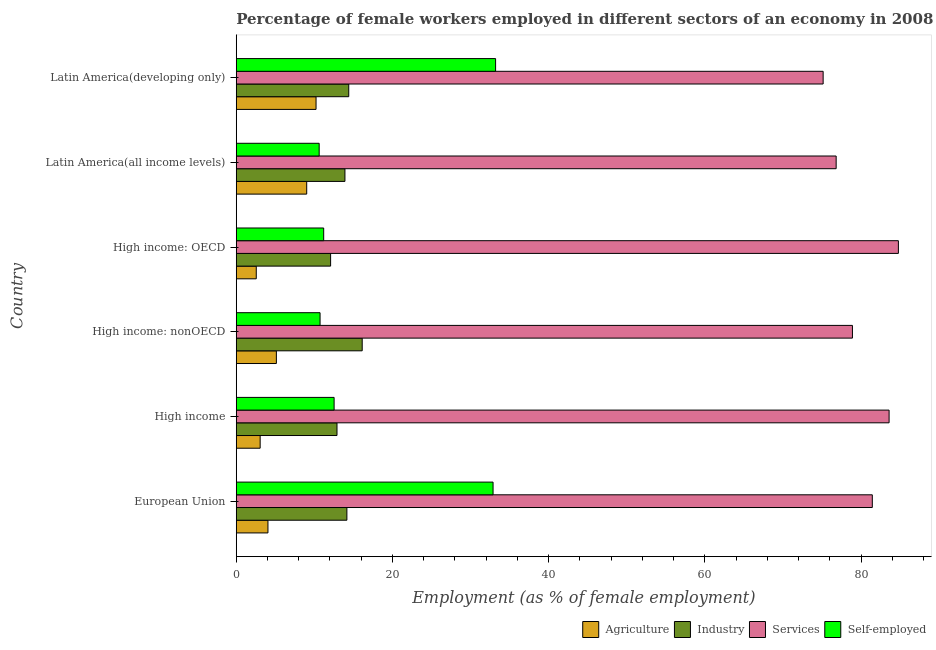How many different coloured bars are there?
Make the answer very short. 4. Are the number of bars per tick equal to the number of legend labels?
Offer a terse response. Yes. How many bars are there on the 3rd tick from the top?
Offer a very short reply. 4. How many bars are there on the 2nd tick from the bottom?
Your answer should be very brief. 4. In how many cases, is the number of bars for a given country not equal to the number of legend labels?
Offer a very short reply. 0. What is the percentage of female workers in industry in High income: OECD?
Keep it short and to the point. 12.08. Across all countries, what is the maximum percentage of female workers in agriculture?
Your answer should be very brief. 10.22. Across all countries, what is the minimum percentage of female workers in services?
Your answer should be very brief. 75.15. In which country was the percentage of female workers in services maximum?
Your answer should be compact. High income: OECD. In which country was the percentage of self employed female workers minimum?
Your answer should be compact. Latin America(all income levels). What is the total percentage of self employed female workers in the graph?
Give a very brief answer. 111.16. What is the difference between the percentage of self employed female workers in High income and that in High income: OECD?
Ensure brevity in your answer.  1.33. What is the difference between the percentage of female workers in agriculture in High income: nonOECD and the percentage of female workers in industry in Latin America(all income levels)?
Provide a short and direct response. -8.78. What is the average percentage of female workers in agriculture per country?
Make the answer very short. 5.68. What is the difference between the percentage of female workers in agriculture and percentage of female workers in services in High income?
Your response must be concise. -80.53. In how many countries, is the percentage of female workers in industry greater than 56 %?
Ensure brevity in your answer.  0. What is the ratio of the percentage of female workers in agriculture in European Union to that in High income?
Give a very brief answer. 1.33. Is the difference between the percentage of self employed female workers in Latin America(all income levels) and Latin America(developing only) greater than the difference between the percentage of female workers in industry in Latin America(all income levels) and Latin America(developing only)?
Your answer should be compact. No. What is the difference between the highest and the second highest percentage of self employed female workers?
Make the answer very short. 0.32. What is the difference between the highest and the lowest percentage of female workers in services?
Make the answer very short. 9.63. What does the 4th bar from the top in High income represents?
Provide a succinct answer. Agriculture. What does the 1st bar from the bottom in High income represents?
Your answer should be very brief. Agriculture. Is it the case that in every country, the sum of the percentage of female workers in agriculture and percentage of female workers in industry is greater than the percentage of female workers in services?
Offer a very short reply. No. How many bars are there?
Your answer should be compact. 24. How many countries are there in the graph?
Make the answer very short. 6. Does the graph contain any zero values?
Offer a terse response. No. How many legend labels are there?
Offer a terse response. 4. What is the title of the graph?
Offer a terse response. Percentage of female workers employed in different sectors of an economy in 2008. What is the label or title of the X-axis?
Make the answer very short. Employment (as % of female employment). What is the Employment (as % of female employment) in Agriculture in European Union?
Your response must be concise. 4.06. What is the Employment (as % of female employment) of Industry in European Union?
Keep it short and to the point. 14.17. What is the Employment (as % of female employment) of Services in European Union?
Provide a succinct answer. 81.44. What is the Employment (as % of female employment) in Self-employed in European Union?
Your response must be concise. 32.88. What is the Employment (as % of female employment) of Agriculture in High income?
Provide a short and direct response. 3.06. What is the Employment (as % of female employment) of Industry in High income?
Your answer should be very brief. 12.9. What is the Employment (as % of female employment) in Services in High income?
Give a very brief answer. 83.59. What is the Employment (as % of female employment) in Self-employed in High income?
Offer a very short reply. 12.53. What is the Employment (as % of female employment) in Agriculture in High income: nonOECD?
Ensure brevity in your answer.  5.14. What is the Employment (as % of female employment) in Industry in High income: nonOECD?
Your answer should be compact. 16.13. What is the Employment (as % of female employment) of Services in High income: nonOECD?
Offer a very short reply. 78.9. What is the Employment (as % of female employment) of Self-employed in High income: nonOECD?
Offer a terse response. 10.73. What is the Employment (as % of female employment) of Agriculture in High income: OECD?
Offer a terse response. 2.56. What is the Employment (as % of female employment) of Industry in High income: OECD?
Provide a succinct answer. 12.08. What is the Employment (as % of female employment) of Services in High income: OECD?
Keep it short and to the point. 84.78. What is the Employment (as % of female employment) in Self-employed in High income: OECD?
Make the answer very short. 11.19. What is the Employment (as % of female employment) of Agriculture in Latin America(all income levels)?
Give a very brief answer. 9.02. What is the Employment (as % of female employment) in Industry in Latin America(all income levels)?
Offer a very short reply. 13.92. What is the Employment (as % of female employment) of Services in Latin America(all income levels)?
Give a very brief answer. 76.81. What is the Employment (as % of female employment) of Self-employed in Latin America(all income levels)?
Offer a terse response. 10.62. What is the Employment (as % of female employment) in Agriculture in Latin America(developing only)?
Ensure brevity in your answer.  10.22. What is the Employment (as % of female employment) of Industry in Latin America(developing only)?
Your answer should be very brief. 14.41. What is the Employment (as % of female employment) of Services in Latin America(developing only)?
Keep it short and to the point. 75.15. What is the Employment (as % of female employment) of Self-employed in Latin America(developing only)?
Offer a very short reply. 33.21. Across all countries, what is the maximum Employment (as % of female employment) in Agriculture?
Ensure brevity in your answer.  10.22. Across all countries, what is the maximum Employment (as % of female employment) of Industry?
Provide a short and direct response. 16.13. Across all countries, what is the maximum Employment (as % of female employment) of Services?
Your answer should be compact. 84.78. Across all countries, what is the maximum Employment (as % of female employment) of Self-employed?
Offer a very short reply. 33.21. Across all countries, what is the minimum Employment (as % of female employment) in Agriculture?
Your answer should be compact. 2.56. Across all countries, what is the minimum Employment (as % of female employment) of Industry?
Keep it short and to the point. 12.08. Across all countries, what is the minimum Employment (as % of female employment) in Services?
Your answer should be compact. 75.15. Across all countries, what is the minimum Employment (as % of female employment) of Self-employed?
Provide a succinct answer. 10.62. What is the total Employment (as % of female employment) of Agriculture in the graph?
Offer a very short reply. 34.05. What is the total Employment (as % of female employment) of Industry in the graph?
Make the answer very short. 83.6. What is the total Employment (as % of female employment) in Services in the graph?
Keep it short and to the point. 480.68. What is the total Employment (as % of female employment) in Self-employed in the graph?
Ensure brevity in your answer.  111.16. What is the difference between the Employment (as % of female employment) of Industry in European Union and that in High income?
Keep it short and to the point. 1.27. What is the difference between the Employment (as % of female employment) in Services in European Union and that in High income?
Your answer should be very brief. -2.15. What is the difference between the Employment (as % of female employment) in Self-employed in European Union and that in High income?
Your answer should be compact. 20.35. What is the difference between the Employment (as % of female employment) in Agriculture in European Union and that in High income: nonOECD?
Provide a succinct answer. -1.08. What is the difference between the Employment (as % of female employment) in Industry in European Union and that in High income: nonOECD?
Your answer should be very brief. -1.96. What is the difference between the Employment (as % of female employment) of Services in European Union and that in High income: nonOECD?
Offer a very short reply. 2.55. What is the difference between the Employment (as % of female employment) in Self-employed in European Union and that in High income: nonOECD?
Your answer should be very brief. 22.15. What is the difference between the Employment (as % of female employment) of Agriculture in European Union and that in High income: OECD?
Give a very brief answer. 1.5. What is the difference between the Employment (as % of female employment) in Industry in European Union and that in High income: OECD?
Offer a very short reply. 2.09. What is the difference between the Employment (as % of female employment) of Services in European Union and that in High income: OECD?
Your response must be concise. -3.34. What is the difference between the Employment (as % of female employment) in Self-employed in European Union and that in High income: OECD?
Provide a succinct answer. 21.69. What is the difference between the Employment (as % of female employment) of Agriculture in European Union and that in Latin America(all income levels)?
Give a very brief answer. -4.96. What is the difference between the Employment (as % of female employment) of Industry in European Union and that in Latin America(all income levels)?
Give a very brief answer. 0.25. What is the difference between the Employment (as % of female employment) in Services in European Union and that in Latin America(all income levels)?
Provide a succinct answer. 4.63. What is the difference between the Employment (as % of female employment) in Self-employed in European Union and that in Latin America(all income levels)?
Provide a succinct answer. 22.27. What is the difference between the Employment (as % of female employment) of Agriculture in European Union and that in Latin America(developing only)?
Ensure brevity in your answer.  -6.16. What is the difference between the Employment (as % of female employment) in Industry in European Union and that in Latin America(developing only)?
Your response must be concise. -0.24. What is the difference between the Employment (as % of female employment) in Services in European Union and that in Latin America(developing only)?
Offer a terse response. 6.3. What is the difference between the Employment (as % of female employment) of Self-employed in European Union and that in Latin America(developing only)?
Ensure brevity in your answer.  -0.32. What is the difference between the Employment (as % of female employment) of Agriculture in High income and that in High income: nonOECD?
Keep it short and to the point. -2.08. What is the difference between the Employment (as % of female employment) in Industry in High income and that in High income: nonOECD?
Keep it short and to the point. -3.23. What is the difference between the Employment (as % of female employment) of Services in High income and that in High income: nonOECD?
Provide a short and direct response. 4.69. What is the difference between the Employment (as % of female employment) in Self-employed in High income and that in High income: nonOECD?
Keep it short and to the point. 1.8. What is the difference between the Employment (as % of female employment) in Agriculture in High income and that in High income: OECD?
Offer a very short reply. 0.5. What is the difference between the Employment (as % of female employment) in Industry in High income and that in High income: OECD?
Your answer should be very brief. 0.82. What is the difference between the Employment (as % of female employment) in Services in High income and that in High income: OECD?
Make the answer very short. -1.19. What is the difference between the Employment (as % of female employment) in Self-employed in High income and that in High income: OECD?
Ensure brevity in your answer.  1.34. What is the difference between the Employment (as % of female employment) of Agriculture in High income and that in Latin America(all income levels)?
Give a very brief answer. -5.96. What is the difference between the Employment (as % of female employment) of Industry in High income and that in Latin America(all income levels)?
Provide a succinct answer. -1.02. What is the difference between the Employment (as % of female employment) in Services in High income and that in Latin America(all income levels)?
Provide a succinct answer. 6.78. What is the difference between the Employment (as % of female employment) of Self-employed in High income and that in Latin America(all income levels)?
Provide a short and direct response. 1.91. What is the difference between the Employment (as % of female employment) in Agriculture in High income and that in Latin America(developing only)?
Provide a short and direct response. -7.16. What is the difference between the Employment (as % of female employment) in Industry in High income and that in Latin America(developing only)?
Give a very brief answer. -1.51. What is the difference between the Employment (as % of female employment) of Services in High income and that in Latin America(developing only)?
Give a very brief answer. 8.44. What is the difference between the Employment (as % of female employment) of Self-employed in High income and that in Latin America(developing only)?
Offer a very short reply. -20.68. What is the difference between the Employment (as % of female employment) in Agriculture in High income: nonOECD and that in High income: OECD?
Your response must be concise. 2.57. What is the difference between the Employment (as % of female employment) in Industry in High income: nonOECD and that in High income: OECD?
Keep it short and to the point. 4.05. What is the difference between the Employment (as % of female employment) in Services in High income: nonOECD and that in High income: OECD?
Offer a very short reply. -5.88. What is the difference between the Employment (as % of female employment) of Self-employed in High income: nonOECD and that in High income: OECD?
Keep it short and to the point. -0.46. What is the difference between the Employment (as % of female employment) in Agriculture in High income: nonOECD and that in Latin America(all income levels)?
Ensure brevity in your answer.  -3.88. What is the difference between the Employment (as % of female employment) in Industry in High income: nonOECD and that in Latin America(all income levels)?
Offer a very short reply. 2.21. What is the difference between the Employment (as % of female employment) in Services in High income: nonOECD and that in Latin America(all income levels)?
Provide a short and direct response. 2.08. What is the difference between the Employment (as % of female employment) in Self-employed in High income: nonOECD and that in Latin America(all income levels)?
Make the answer very short. 0.11. What is the difference between the Employment (as % of female employment) of Agriculture in High income: nonOECD and that in Latin America(developing only)?
Your answer should be very brief. -5.08. What is the difference between the Employment (as % of female employment) in Industry in High income: nonOECD and that in Latin America(developing only)?
Your answer should be very brief. 1.72. What is the difference between the Employment (as % of female employment) of Services in High income: nonOECD and that in Latin America(developing only)?
Your answer should be compact. 3.75. What is the difference between the Employment (as % of female employment) in Self-employed in High income: nonOECD and that in Latin America(developing only)?
Provide a short and direct response. -22.48. What is the difference between the Employment (as % of female employment) of Agriculture in High income: OECD and that in Latin America(all income levels)?
Make the answer very short. -6.46. What is the difference between the Employment (as % of female employment) of Industry in High income: OECD and that in Latin America(all income levels)?
Provide a short and direct response. -1.84. What is the difference between the Employment (as % of female employment) of Services in High income: OECD and that in Latin America(all income levels)?
Offer a terse response. 7.97. What is the difference between the Employment (as % of female employment) of Self-employed in High income: OECD and that in Latin America(all income levels)?
Keep it short and to the point. 0.58. What is the difference between the Employment (as % of female employment) in Agriculture in High income: OECD and that in Latin America(developing only)?
Offer a very short reply. -7.65. What is the difference between the Employment (as % of female employment) of Industry in High income: OECD and that in Latin America(developing only)?
Ensure brevity in your answer.  -2.32. What is the difference between the Employment (as % of female employment) in Services in High income: OECD and that in Latin America(developing only)?
Ensure brevity in your answer.  9.63. What is the difference between the Employment (as % of female employment) in Self-employed in High income: OECD and that in Latin America(developing only)?
Offer a very short reply. -22.01. What is the difference between the Employment (as % of female employment) in Agriculture in Latin America(all income levels) and that in Latin America(developing only)?
Your answer should be compact. -1.2. What is the difference between the Employment (as % of female employment) in Industry in Latin America(all income levels) and that in Latin America(developing only)?
Keep it short and to the point. -0.49. What is the difference between the Employment (as % of female employment) of Services in Latin America(all income levels) and that in Latin America(developing only)?
Ensure brevity in your answer.  1.67. What is the difference between the Employment (as % of female employment) in Self-employed in Latin America(all income levels) and that in Latin America(developing only)?
Ensure brevity in your answer.  -22.59. What is the difference between the Employment (as % of female employment) in Agriculture in European Union and the Employment (as % of female employment) in Industry in High income?
Offer a terse response. -8.84. What is the difference between the Employment (as % of female employment) of Agriculture in European Union and the Employment (as % of female employment) of Services in High income?
Your answer should be very brief. -79.53. What is the difference between the Employment (as % of female employment) in Agriculture in European Union and the Employment (as % of female employment) in Self-employed in High income?
Your answer should be compact. -8.47. What is the difference between the Employment (as % of female employment) in Industry in European Union and the Employment (as % of female employment) in Services in High income?
Offer a terse response. -69.43. What is the difference between the Employment (as % of female employment) in Industry in European Union and the Employment (as % of female employment) in Self-employed in High income?
Your answer should be very brief. 1.64. What is the difference between the Employment (as % of female employment) in Services in European Union and the Employment (as % of female employment) in Self-employed in High income?
Offer a very short reply. 68.91. What is the difference between the Employment (as % of female employment) of Agriculture in European Union and the Employment (as % of female employment) of Industry in High income: nonOECD?
Your answer should be very brief. -12.07. What is the difference between the Employment (as % of female employment) in Agriculture in European Union and the Employment (as % of female employment) in Services in High income: nonOECD?
Provide a succinct answer. -74.84. What is the difference between the Employment (as % of female employment) in Agriculture in European Union and the Employment (as % of female employment) in Self-employed in High income: nonOECD?
Keep it short and to the point. -6.67. What is the difference between the Employment (as % of female employment) of Industry in European Union and the Employment (as % of female employment) of Services in High income: nonOECD?
Offer a very short reply. -64.73. What is the difference between the Employment (as % of female employment) in Industry in European Union and the Employment (as % of female employment) in Self-employed in High income: nonOECD?
Give a very brief answer. 3.43. What is the difference between the Employment (as % of female employment) of Services in European Union and the Employment (as % of female employment) of Self-employed in High income: nonOECD?
Provide a short and direct response. 70.71. What is the difference between the Employment (as % of female employment) of Agriculture in European Union and the Employment (as % of female employment) of Industry in High income: OECD?
Your answer should be compact. -8.02. What is the difference between the Employment (as % of female employment) of Agriculture in European Union and the Employment (as % of female employment) of Services in High income: OECD?
Ensure brevity in your answer.  -80.72. What is the difference between the Employment (as % of female employment) in Agriculture in European Union and the Employment (as % of female employment) in Self-employed in High income: OECD?
Offer a very short reply. -7.14. What is the difference between the Employment (as % of female employment) in Industry in European Union and the Employment (as % of female employment) in Services in High income: OECD?
Offer a very short reply. -70.62. What is the difference between the Employment (as % of female employment) of Industry in European Union and the Employment (as % of female employment) of Self-employed in High income: OECD?
Keep it short and to the point. 2.97. What is the difference between the Employment (as % of female employment) in Services in European Union and the Employment (as % of female employment) in Self-employed in High income: OECD?
Keep it short and to the point. 70.25. What is the difference between the Employment (as % of female employment) in Agriculture in European Union and the Employment (as % of female employment) in Industry in Latin America(all income levels)?
Offer a terse response. -9.86. What is the difference between the Employment (as % of female employment) of Agriculture in European Union and the Employment (as % of female employment) of Services in Latin America(all income levels)?
Provide a short and direct response. -72.75. What is the difference between the Employment (as % of female employment) of Agriculture in European Union and the Employment (as % of female employment) of Self-employed in Latin America(all income levels)?
Provide a short and direct response. -6.56. What is the difference between the Employment (as % of female employment) of Industry in European Union and the Employment (as % of female employment) of Services in Latin America(all income levels)?
Your answer should be compact. -62.65. What is the difference between the Employment (as % of female employment) in Industry in European Union and the Employment (as % of female employment) in Self-employed in Latin America(all income levels)?
Give a very brief answer. 3.55. What is the difference between the Employment (as % of female employment) in Services in European Union and the Employment (as % of female employment) in Self-employed in Latin America(all income levels)?
Provide a succinct answer. 70.83. What is the difference between the Employment (as % of female employment) of Agriculture in European Union and the Employment (as % of female employment) of Industry in Latin America(developing only)?
Ensure brevity in your answer.  -10.35. What is the difference between the Employment (as % of female employment) of Agriculture in European Union and the Employment (as % of female employment) of Services in Latin America(developing only)?
Provide a succinct answer. -71.09. What is the difference between the Employment (as % of female employment) of Agriculture in European Union and the Employment (as % of female employment) of Self-employed in Latin America(developing only)?
Your answer should be compact. -29.15. What is the difference between the Employment (as % of female employment) of Industry in European Union and the Employment (as % of female employment) of Services in Latin America(developing only)?
Keep it short and to the point. -60.98. What is the difference between the Employment (as % of female employment) in Industry in European Union and the Employment (as % of female employment) in Self-employed in Latin America(developing only)?
Offer a very short reply. -19.04. What is the difference between the Employment (as % of female employment) in Services in European Union and the Employment (as % of female employment) in Self-employed in Latin America(developing only)?
Keep it short and to the point. 48.24. What is the difference between the Employment (as % of female employment) of Agriculture in High income and the Employment (as % of female employment) of Industry in High income: nonOECD?
Provide a succinct answer. -13.07. What is the difference between the Employment (as % of female employment) in Agriculture in High income and the Employment (as % of female employment) in Services in High income: nonOECD?
Provide a short and direct response. -75.84. What is the difference between the Employment (as % of female employment) of Agriculture in High income and the Employment (as % of female employment) of Self-employed in High income: nonOECD?
Offer a very short reply. -7.67. What is the difference between the Employment (as % of female employment) in Industry in High income and the Employment (as % of female employment) in Services in High income: nonOECD?
Ensure brevity in your answer.  -66. What is the difference between the Employment (as % of female employment) in Industry in High income and the Employment (as % of female employment) in Self-employed in High income: nonOECD?
Make the answer very short. 2.17. What is the difference between the Employment (as % of female employment) of Services in High income and the Employment (as % of female employment) of Self-employed in High income: nonOECD?
Provide a succinct answer. 72.86. What is the difference between the Employment (as % of female employment) of Agriculture in High income and the Employment (as % of female employment) of Industry in High income: OECD?
Offer a terse response. -9.02. What is the difference between the Employment (as % of female employment) in Agriculture in High income and the Employment (as % of female employment) in Services in High income: OECD?
Your answer should be very brief. -81.72. What is the difference between the Employment (as % of female employment) of Agriculture in High income and the Employment (as % of female employment) of Self-employed in High income: OECD?
Your answer should be very brief. -8.13. What is the difference between the Employment (as % of female employment) of Industry in High income and the Employment (as % of female employment) of Services in High income: OECD?
Provide a succinct answer. -71.88. What is the difference between the Employment (as % of female employment) in Industry in High income and the Employment (as % of female employment) in Self-employed in High income: OECD?
Give a very brief answer. 1.7. What is the difference between the Employment (as % of female employment) in Services in High income and the Employment (as % of female employment) in Self-employed in High income: OECD?
Make the answer very short. 72.4. What is the difference between the Employment (as % of female employment) of Agriculture in High income and the Employment (as % of female employment) of Industry in Latin America(all income levels)?
Provide a short and direct response. -10.86. What is the difference between the Employment (as % of female employment) in Agriculture in High income and the Employment (as % of female employment) in Services in Latin America(all income levels)?
Offer a terse response. -73.75. What is the difference between the Employment (as % of female employment) of Agriculture in High income and the Employment (as % of female employment) of Self-employed in Latin America(all income levels)?
Offer a very short reply. -7.56. What is the difference between the Employment (as % of female employment) of Industry in High income and the Employment (as % of female employment) of Services in Latin America(all income levels)?
Provide a succinct answer. -63.91. What is the difference between the Employment (as % of female employment) in Industry in High income and the Employment (as % of female employment) in Self-employed in Latin America(all income levels)?
Make the answer very short. 2.28. What is the difference between the Employment (as % of female employment) of Services in High income and the Employment (as % of female employment) of Self-employed in Latin America(all income levels)?
Offer a terse response. 72.98. What is the difference between the Employment (as % of female employment) in Agriculture in High income and the Employment (as % of female employment) in Industry in Latin America(developing only)?
Provide a succinct answer. -11.34. What is the difference between the Employment (as % of female employment) of Agriculture in High income and the Employment (as % of female employment) of Services in Latin America(developing only)?
Your answer should be compact. -72.09. What is the difference between the Employment (as % of female employment) of Agriculture in High income and the Employment (as % of female employment) of Self-employed in Latin America(developing only)?
Make the answer very short. -30.15. What is the difference between the Employment (as % of female employment) in Industry in High income and the Employment (as % of female employment) in Services in Latin America(developing only)?
Provide a succinct answer. -62.25. What is the difference between the Employment (as % of female employment) of Industry in High income and the Employment (as % of female employment) of Self-employed in Latin America(developing only)?
Make the answer very short. -20.31. What is the difference between the Employment (as % of female employment) in Services in High income and the Employment (as % of female employment) in Self-employed in Latin America(developing only)?
Offer a very short reply. 50.39. What is the difference between the Employment (as % of female employment) in Agriculture in High income: nonOECD and the Employment (as % of female employment) in Industry in High income: OECD?
Provide a short and direct response. -6.94. What is the difference between the Employment (as % of female employment) of Agriculture in High income: nonOECD and the Employment (as % of female employment) of Services in High income: OECD?
Make the answer very short. -79.65. What is the difference between the Employment (as % of female employment) in Agriculture in High income: nonOECD and the Employment (as % of female employment) in Self-employed in High income: OECD?
Ensure brevity in your answer.  -6.06. What is the difference between the Employment (as % of female employment) in Industry in High income: nonOECD and the Employment (as % of female employment) in Services in High income: OECD?
Ensure brevity in your answer.  -68.66. What is the difference between the Employment (as % of female employment) in Industry in High income: nonOECD and the Employment (as % of female employment) in Self-employed in High income: OECD?
Offer a terse response. 4.93. What is the difference between the Employment (as % of female employment) in Services in High income: nonOECD and the Employment (as % of female employment) in Self-employed in High income: OECD?
Your answer should be compact. 67.7. What is the difference between the Employment (as % of female employment) of Agriculture in High income: nonOECD and the Employment (as % of female employment) of Industry in Latin America(all income levels)?
Provide a short and direct response. -8.78. What is the difference between the Employment (as % of female employment) in Agriculture in High income: nonOECD and the Employment (as % of female employment) in Services in Latin America(all income levels)?
Offer a very short reply. -71.68. What is the difference between the Employment (as % of female employment) of Agriculture in High income: nonOECD and the Employment (as % of female employment) of Self-employed in Latin America(all income levels)?
Make the answer very short. -5.48. What is the difference between the Employment (as % of female employment) in Industry in High income: nonOECD and the Employment (as % of female employment) in Services in Latin America(all income levels)?
Ensure brevity in your answer.  -60.69. What is the difference between the Employment (as % of female employment) of Industry in High income: nonOECD and the Employment (as % of female employment) of Self-employed in Latin America(all income levels)?
Make the answer very short. 5.51. What is the difference between the Employment (as % of female employment) in Services in High income: nonOECD and the Employment (as % of female employment) in Self-employed in Latin America(all income levels)?
Offer a very short reply. 68.28. What is the difference between the Employment (as % of female employment) in Agriculture in High income: nonOECD and the Employment (as % of female employment) in Industry in Latin America(developing only)?
Give a very brief answer. -9.27. What is the difference between the Employment (as % of female employment) in Agriculture in High income: nonOECD and the Employment (as % of female employment) in Services in Latin America(developing only)?
Offer a terse response. -70.01. What is the difference between the Employment (as % of female employment) of Agriculture in High income: nonOECD and the Employment (as % of female employment) of Self-employed in Latin America(developing only)?
Your answer should be compact. -28.07. What is the difference between the Employment (as % of female employment) in Industry in High income: nonOECD and the Employment (as % of female employment) in Services in Latin America(developing only)?
Your answer should be compact. -59.02. What is the difference between the Employment (as % of female employment) of Industry in High income: nonOECD and the Employment (as % of female employment) of Self-employed in Latin America(developing only)?
Give a very brief answer. -17.08. What is the difference between the Employment (as % of female employment) of Services in High income: nonOECD and the Employment (as % of female employment) of Self-employed in Latin America(developing only)?
Ensure brevity in your answer.  45.69. What is the difference between the Employment (as % of female employment) in Agriculture in High income: OECD and the Employment (as % of female employment) in Industry in Latin America(all income levels)?
Keep it short and to the point. -11.36. What is the difference between the Employment (as % of female employment) of Agriculture in High income: OECD and the Employment (as % of female employment) of Services in Latin America(all income levels)?
Give a very brief answer. -74.25. What is the difference between the Employment (as % of female employment) in Agriculture in High income: OECD and the Employment (as % of female employment) in Self-employed in Latin America(all income levels)?
Your response must be concise. -8.06. What is the difference between the Employment (as % of female employment) of Industry in High income: OECD and the Employment (as % of female employment) of Services in Latin America(all income levels)?
Your answer should be compact. -64.73. What is the difference between the Employment (as % of female employment) of Industry in High income: OECD and the Employment (as % of female employment) of Self-employed in Latin America(all income levels)?
Keep it short and to the point. 1.46. What is the difference between the Employment (as % of female employment) in Services in High income: OECD and the Employment (as % of female employment) in Self-employed in Latin America(all income levels)?
Keep it short and to the point. 74.17. What is the difference between the Employment (as % of female employment) in Agriculture in High income: OECD and the Employment (as % of female employment) in Industry in Latin America(developing only)?
Your answer should be compact. -11.84. What is the difference between the Employment (as % of female employment) of Agriculture in High income: OECD and the Employment (as % of female employment) of Services in Latin America(developing only)?
Provide a short and direct response. -72.59. What is the difference between the Employment (as % of female employment) of Agriculture in High income: OECD and the Employment (as % of female employment) of Self-employed in Latin America(developing only)?
Give a very brief answer. -30.65. What is the difference between the Employment (as % of female employment) of Industry in High income: OECD and the Employment (as % of female employment) of Services in Latin America(developing only)?
Your answer should be compact. -63.07. What is the difference between the Employment (as % of female employment) in Industry in High income: OECD and the Employment (as % of female employment) in Self-employed in Latin America(developing only)?
Ensure brevity in your answer.  -21.13. What is the difference between the Employment (as % of female employment) of Services in High income: OECD and the Employment (as % of female employment) of Self-employed in Latin America(developing only)?
Keep it short and to the point. 51.58. What is the difference between the Employment (as % of female employment) of Agriculture in Latin America(all income levels) and the Employment (as % of female employment) of Industry in Latin America(developing only)?
Give a very brief answer. -5.39. What is the difference between the Employment (as % of female employment) in Agriculture in Latin America(all income levels) and the Employment (as % of female employment) in Services in Latin America(developing only)?
Make the answer very short. -66.13. What is the difference between the Employment (as % of female employment) of Agriculture in Latin America(all income levels) and the Employment (as % of female employment) of Self-employed in Latin America(developing only)?
Your response must be concise. -24.19. What is the difference between the Employment (as % of female employment) in Industry in Latin America(all income levels) and the Employment (as % of female employment) in Services in Latin America(developing only)?
Your response must be concise. -61.23. What is the difference between the Employment (as % of female employment) in Industry in Latin America(all income levels) and the Employment (as % of female employment) in Self-employed in Latin America(developing only)?
Your answer should be very brief. -19.29. What is the difference between the Employment (as % of female employment) in Services in Latin America(all income levels) and the Employment (as % of female employment) in Self-employed in Latin America(developing only)?
Offer a very short reply. 43.61. What is the average Employment (as % of female employment) of Agriculture per country?
Provide a short and direct response. 5.68. What is the average Employment (as % of female employment) of Industry per country?
Provide a succinct answer. 13.93. What is the average Employment (as % of female employment) in Services per country?
Provide a succinct answer. 80.11. What is the average Employment (as % of female employment) in Self-employed per country?
Give a very brief answer. 18.53. What is the difference between the Employment (as % of female employment) in Agriculture and Employment (as % of female employment) in Industry in European Union?
Offer a very short reply. -10.11. What is the difference between the Employment (as % of female employment) of Agriculture and Employment (as % of female employment) of Services in European Union?
Make the answer very short. -77.39. What is the difference between the Employment (as % of female employment) in Agriculture and Employment (as % of female employment) in Self-employed in European Union?
Offer a terse response. -28.82. What is the difference between the Employment (as % of female employment) in Industry and Employment (as % of female employment) in Services in European Union?
Provide a succinct answer. -67.28. What is the difference between the Employment (as % of female employment) in Industry and Employment (as % of female employment) in Self-employed in European Union?
Offer a very short reply. -18.72. What is the difference between the Employment (as % of female employment) in Services and Employment (as % of female employment) in Self-employed in European Union?
Offer a very short reply. 48.56. What is the difference between the Employment (as % of female employment) of Agriculture and Employment (as % of female employment) of Industry in High income?
Make the answer very short. -9.84. What is the difference between the Employment (as % of female employment) in Agriculture and Employment (as % of female employment) in Services in High income?
Your answer should be compact. -80.53. What is the difference between the Employment (as % of female employment) of Agriculture and Employment (as % of female employment) of Self-employed in High income?
Your answer should be compact. -9.47. What is the difference between the Employment (as % of female employment) of Industry and Employment (as % of female employment) of Services in High income?
Ensure brevity in your answer.  -70.69. What is the difference between the Employment (as % of female employment) in Industry and Employment (as % of female employment) in Self-employed in High income?
Provide a short and direct response. 0.37. What is the difference between the Employment (as % of female employment) in Services and Employment (as % of female employment) in Self-employed in High income?
Give a very brief answer. 71.06. What is the difference between the Employment (as % of female employment) of Agriculture and Employment (as % of female employment) of Industry in High income: nonOECD?
Provide a short and direct response. -10.99. What is the difference between the Employment (as % of female employment) in Agriculture and Employment (as % of female employment) in Services in High income: nonOECD?
Your answer should be compact. -73.76. What is the difference between the Employment (as % of female employment) of Agriculture and Employment (as % of female employment) of Self-employed in High income: nonOECD?
Offer a terse response. -5.6. What is the difference between the Employment (as % of female employment) of Industry and Employment (as % of female employment) of Services in High income: nonOECD?
Offer a terse response. -62.77. What is the difference between the Employment (as % of female employment) in Industry and Employment (as % of female employment) in Self-employed in High income: nonOECD?
Offer a terse response. 5.4. What is the difference between the Employment (as % of female employment) in Services and Employment (as % of female employment) in Self-employed in High income: nonOECD?
Offer a terse response. 68.17. What is the difference between the Employment (as % of female employment) in Agriculture and Employment (as % of female employment) in Industry in High income: OECD?
Keep it short and to the point. -9.52. What is the difference between the Employment (as % of female employment) in Agriculture and Employment (as % of female employment) in Services in High income: OECD?
Offer a terse response. -82.22. What is the difference between the Employment (as % of female employment) of Agriculture and Employment (as % of female employment) of Self-employed in High income: OECD?
Keep it short and to the point. -8.63. What is the difference between the Employment (as % of female employment) in Industry and Employment (as % of female employment) in Services in High income: OECD?
Make the answer very short. -72.7. What is the difference between the Employment (as % of female employment) of Industry and Employment (as % of female employment) of Self-employed in High income: OECD?
Your answer should be very brief. 0.89. What is the difference between the Employment (as % of female employment) of Services and Employment (as % of female employment) of Self-employed in High income: OECD?
Offer a very short reply. 73.59. What is the difference between the Employment (as % of female employment) in Agriculture and Employment (as % of female employment) in Industry in Latin America(all income levels)?
Make the answer very short. -4.9. What is the difference between the Employment (as % of female employment) of Agriculture and Employment (as % of female employment) of Services in Latin America(all income levels)?
Your response must be concise. -67.79. What is the difference between the Employment (as % of female employment) in Agriculture and Employment (as % of female employment) in Self-employed in Latin America(all income levels)?
Ensure brevity in your answer.  -1.6. What is the difference between the Employment (as % of female employment) in Industry and Employment (as % of female employment) in Services in Latin America(all income levels)?
Offer a terse response. -62.9. What is the difference between the Employment (as % of female employment) of Industry and Employment (as % of female employment) of Self-employed in Latin America(all income levels)?
Your answer should be very brief. 3.3. What is the difference between the Employment (as % of female employment) of Services and Employment (as % of female employment) of Self-employed in Latin America(all income levels)?
Your response must be concise. 66.2. What is the difference between the Employment (as % of female employment) in Agriculture and Employment (as % of female employment) in Industry in Latin America(developing only)?
Provide a short and direct response. -4.19. What is the difference between the Employment (as % of female employment) of Agriculture and Employment (as % of female employment) of Services in Latin America(developing only)?
Your answer should be compact. -64.93. What is the difference between the Employment (as % of female employment) in Agriculture and Employment (as % of female employment) in Self-employed in Latin America(developing only)?
Give a very brief answer. -22.99. What is the difference between the Employment (as % of female employment) of Industry and Employment (as % of female employment) of Services in Latin America(developing only)?
Offer a terse response. -60.74. What is the difference between the Employment (as % of female employment) of Industry and Employment (as % of female employment) of Self-employed in Latin America(developing only)?
Provide a succinct answer. -18.8. What is the difference between the Employment (as % of female employment) of Services and Employment (as % of female employment) of Self-employed in Latin America(developing only)?
Your answer should be compact. 41.94. What is the ratio of the Employment (as % of female employment) of Agriculture in European Union to that in High income?
Make the answer very short. 1.33. What is the ratio of the Employment (as % of female employment) in Industry in European Union to that in High income?
Offer a very short reply. 1.1. What is the ratio of the Employment (as % of female employment) in Services in European Union to that in High income?
Offer a very short reply. 0.97. What is the ratio of the Employment (as % of female employment) of Self-employed in European Union to that in High income?
Offer a very short reply. 2.62. What is the ratio of the Employment (as % of female employment) of Agriculture in European Union to that in High income: nonOECD?
Your response must be concise. 0.79. What is the ratio of the Employment (as % of female employment) in Industry in European Union to that in High income: nonOECD?
Offer a terse response. 0.88. What is the ratio of the Employment (as % of female employment) of Services in European Union to that in High income: nonOECD?
Ensure brevity in your answer.  1.03. What is the ratio of the Employment (as % of female employment) in Self-employed in European Union to that in High income: nonOECD?
Provide a short and direct response. 3.06. What is the ratio of the Employment (as % of female employment) in Agriculture in European Union to that in High income: OECD?
Your answer should be very brief. 1.58. What is the ratio of the Employment (as % of female employment) of Industry in European Union to that in High income: OECD?
Keep it short and to the point. 1.17. What is the ratio of the Employment (as % of female employment) in Services in European Union to that in High income: OECD?
Offer a terse response. 0.96. What is the ratio of the Employment (as % of female employment) of Self-employed in European Union to that in High income: OECD?
Offer a terse response. 2.94. What is the ratio of the Employment (as % of female employment) of Agriculture in European Union to that in Latin America(all income levels)?
Your response must be concise. 0.45. What is the ratio of the Employment (as % of female employment) in Industry in European Union to that in Latin America(all income levels)?
Your response must be concise. 1.02. What is the ratio of the Employment (as % of female employment) of Services in European Union to that in Latin America(all income levels)?
Make the answer very short. 1.06. What is the ratio of the Employment (as % of female employment) in Self-employed in European Union to that in Latin America(all income levels)?
Ensure brevity in your answer.  3.1. What is the ratio of the Employment (as % of female employment) in Agriculture in European Union to that in Latin America(developing only)?
Offer a very short reply. 0.4. What is the ratio of the Employment (as % of female employment) in Industry in European Union to that in Latin America(developing only)?
Give a very brief answer. 0.98. What is the ratio of the Employment (as % of female employment) in Services in European Union to that in Latin America(developing only)?
Offer a very short reply. 1.08. What is the ratio of the Employment (as % of female employment) of Self-employed in European Union to that in Latin America(developing only)?
Ensure brevity in your answer.  0.99. What is the ratio of the Employment (as % of female employment) of Agriculture in High income to that in High income: nonOECD?
Your response must be concise. 0.6. What is the ratio of the Employment (as % of female employment) in Industry in High income to that in High income: nonOECD?
Offer a very short reply. 0.8. What is the ratio of the Employment (as % of female employment) of Services in High income to that in High income: nonOECD?
Your response must be concise. 1.06. What is the ratio of the Employment (as % of female employment) in Self-employed in High income to that in High income: nonOECD?
Your answer should be very brief. 1.17. What is the ratio of the Employment (as % of female employment) in Agriculture in High income to that in High income: OECD?
Provide a succinct answer. 1.2. What is the ratio of the Employment (as % of female employment) in Industry in High income to that in High income: OECD?
Provide a short and direct response. 1.07. What is the ratio of the Employment (as % of female employment) of Self-employed in High income to that in High income: OECD?
Keep it short and to the point. 1.12. What is the ratio of the Employment (as % of female employment) in Agriculture in High income to that in Latin America(all income levels)?
Ensure brevity in your answer.  0.34. What is the ratio of the Employment (as % of female employment) of Industry in High income to that in Latin America(all income levels)?
Keep it short and to the point. 0.93. What is the ratio of the Employment (as % of female employment) in Services in High income to that in Latin America(all income levels)?
Keep it short and to the point. 1.09. What is the ratio of the Employment (as % of female employment) in Self-employed in High income to that in Latin America(all income levels)?
Your response must be concise. 1.18. What is the ratio of the Employment (as % of female employment) in Agriculture in High income to that in Latin America(developing only)?
Give a very brief answer. 0.3. What is the ratio of the Employment (as % of female employment) in Industry in High income to that in Latin America(developing only)?
Your answer should be compact. 0.9. What is the ratio of the Employment (as % of female employment) of Services in High income to that in Latin America(developing only)?
Ensure brevity in your answer.  1.11. What is the ratio of the Employment (as % of female employment) of Self-employed in High income to that in Latin America(developing only)?
Ensure brevity in your answer.  0.38. What is the ratio of the Employment (as % of female employment) in Agriculture in High income: nonOECD to that in High income: OECD?
Your answer should be compact. 2.01. What is the ratio of the Employment (as % of female employment) of Industry in High income: nonOECD to that in High income: OECD?
Your answer should be compact. 1.33. What is the ratio of the Employment (as % of female employment) of Services in High income: nonOECD to that in High income: OECD?
Your response must be concise. 0.93. What is the ratio of the Employment (as % of female employment) of Self-employed in High income: nonOECD to that in High income: OECD?
Provide a short and direct response. 0.96. What is the ratio of the Employment (as % of female employment) of Agriculture in High income: nonOECD to that in Latin America(all income levels)?
Your response must be concise. 0.57. What is the ratio of the Employment (as % of female employment) of Industry in High income: nonOECD to that in Latin America(all income levels)?
Offer a terse response. 1.16. What is the ratio of the Employment (as % of female employment) of Services in High income: nonOECD to that in Latin America(all income levels)?
Provide a succinct answer. 1.03. What is the ratio of the Employment (as % of female employment) in Self-employed in High income: nonOECD to that in Latin America(all income levels)?
Your answer should be compact. 1.01. What is the ratio of the Employment (as % of female employment) in Agriculture in High income: nonOECD to that in Latin America(developing only)?
Your response must be concise. 0.5. What is the ratio of the Employment (as % of female employment) in Industry in High income: nonOECD to that in Latin America(developing only)?
Give a very brief answer. 1.12. What is the ratio of the Employment (as % of female employment) of Services in High income: nonOECD to that in Latin America(developing only)?
Your answer should be very brief. 1.05. What is the ratio of the Employment (as % of female employment) in Self-employed in High income: nonOECD to that in Latin America(developing only)?
Your answer should be very brief. 0.32. What is the ratio of the Employment (as % of female employment) in Agriculture in High income: OECD to that in Latin America(all income levels)?
Provide a succinct answer. 0.28. What is the ratio of the Employment (as % of female employment) in Industry in High income: OECD to that in Latin America(all income levels)?
Make the answer very short. 0.87. What is the ratio of the Employment (as % of female employment) in Services in High income: OECD to that in Latin America(all income levels)?
Provide a short and direct response. 1.1. What is the ratio of the Employment (as % of female employment) of Self-employed in High income: OECD to that in Latin America(all income levels)?
Your response must be concise. 1.05. What is the ratio of the Employment (as % of female employment) in Agriculture in High income: OECD to that in Latin America(developing only)?
Keep it short and to the point. 0.25. What is the ratio of the Employment (as % of female employment) of Industry in High income: OECD to that in Latin America(developing only)?
Provide a succinct answer. 0.84. What is the ratio of the Employment (as % of female employment) in Services in High income: OECD to that in Latin America(developing only)?
Your answer should be compact. 1.13. What is the ratio of the Employment (as % of female employment) of Self-employed in High income: OECD to that in Latin America(developing only)?
Your answer should be compact. 0.34. What is the ratio of the Employment (as % of female employment) of Agriculture in Latin America(all income levels) to that in Latin America(developing only)?
Provide a succinct answer. 0.88. What is the ratio of the Employment (as % of female employment) in Industry in Latin America(all income levels) to that in Latin America(developing only)?
Your response must be concise. 0.97. What is the ratio of the Employment (as % of female employment) of Services in Latin America(all income levels) to that in Latin America(developing only)?
Offer a terse response. 1.02. What is the ratio of the Employment (as % of female employment) of Self-employed in Latin America(all income levels) to that in Latin America(developing only)?
Give a very brief answer. 0.32. What is the difference between the highest and the second highest Employment (as % of female employment) in Agriculture?
Make the answer very short. 1.2. What is the difference between the highest and the second highest Employment (as % of female employment) of Industry?
Provide a short and direct response. 1.72. What is the difference between the highest and the second highest Employment (as % of female employment) of Services?
Your answer should be very brief. 1.19. What is the difference between the highest and the second highest Employment (as % of female employment) in Self-employed?
Offer a very short reply. 0.32. What is the difference between the highest and the lowest Employment (as % of female employment) in Agriculture?
Provide a short and direct response. 7.65. What is the difference between the highest and the lowest Employment (as % of female employment) of Industry?
Offer a very short reply. 4.05. What is the difference between the highest and the lowest Employment (as % of female employment) of Services?
Your answer should be compact. 9.63. What is the difference between the highest and the lowest Employment (as % of female employment) of Self-employed?
Offer a very short reply. 22.59. 